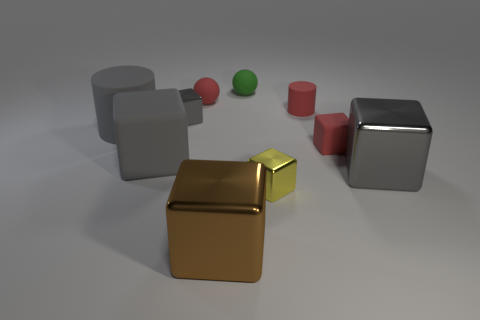There is a large matte thing that is the same shape as the small gray thing; what color is it?
Your response must be concise. Gray. How many things are the same material as the red cylinder?
Keep it short and to the point. 5. What number of large cubes are there?
Make the answer very short. 3. There is a yellow cube; is it the same size as the cylinder that is on the left side of the tiny green thing?
Make the answer very short. No. What material is the red thing that is in front of the cylinder that is left of the green matte object?
Provide a short and direct response. Rubber. There is a block that is in front of the tiny metallic block in front of the shiny block that is right of the small red cylinder; what size is it?
Keep it short and to the point. Large. There is a large brown shiny thing; is it the same shape as the large gray thing to the right of the big brown block?
Your answer should be very brief. Yes. What is the material of the big gray cylinder?
Make the answer very short. Rubber. How many shiny things are either gray cylinders or large red spheres?
Offer a very short reply. 0. Are there fewer large gray things behind the green matte sphere than large gray cylinders that are behind the small red sphere?
Your response must be concise. No. 